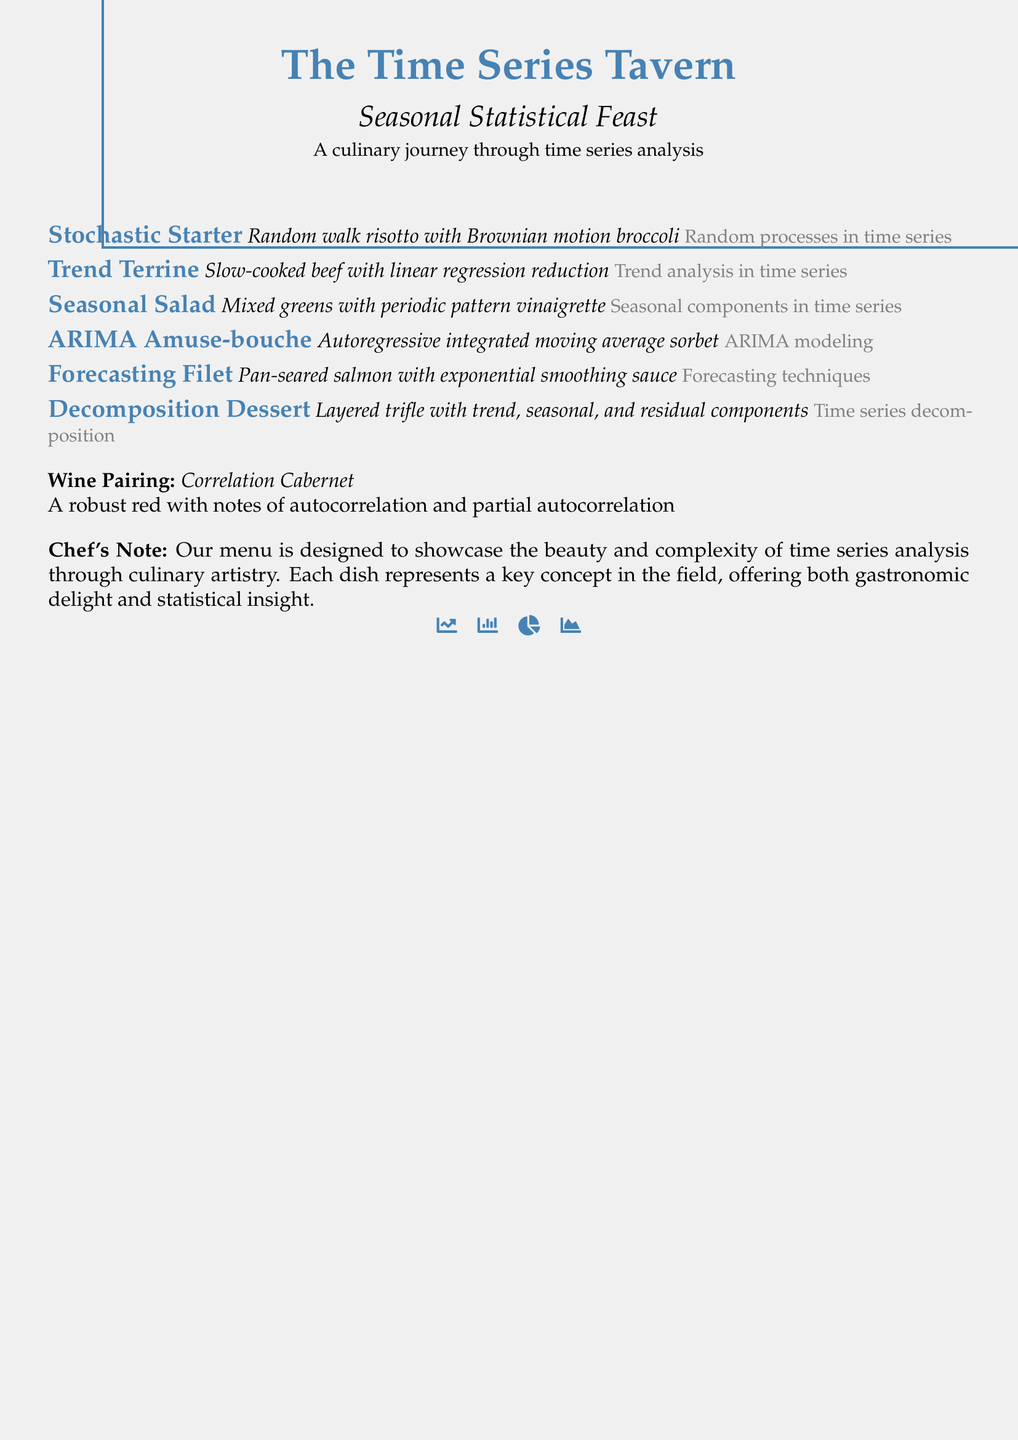What is the name of the restaurant? The name of the restaurant is prominently displayed at the top of the menu.
Answer: The Time Series Tavern What is the first course in the menu? The first course listed is the Stochastic Starter, which is detailed immediately following the introduction.
Answer: Stochastic Starter What type of sauce accompanies the Forecasting Filet? The sauce is explicitly mentioned in the description of the Forecasting Filet course.
Answer: Exponential smoothing sauce What culinary concept does the Seasonal Salad represent? The description provides insight into what statistical concept the Seasonal Salad reflects in time series analysis.
Answer: Seasonal components in time series What is served as the wine pairing? A specific wine is suggested to accompany the meal, noted in the wine pairing section.
Answer: Correlation Cabernet How many courses are included in the menu? By counting the courses listed in the document, the total number can be determined.
Answer: Six What type of dish is the ARIMA Amuse-bouche? The name of the dish is presented which highlights the dish's relation to ARIMA modeling.
Answer: Sorbet What is the chef's note intended to convey? The chef’s note includes a brief explanation about the concept behind the menu design.
Answer: The beauty and complexity of time series analysis 